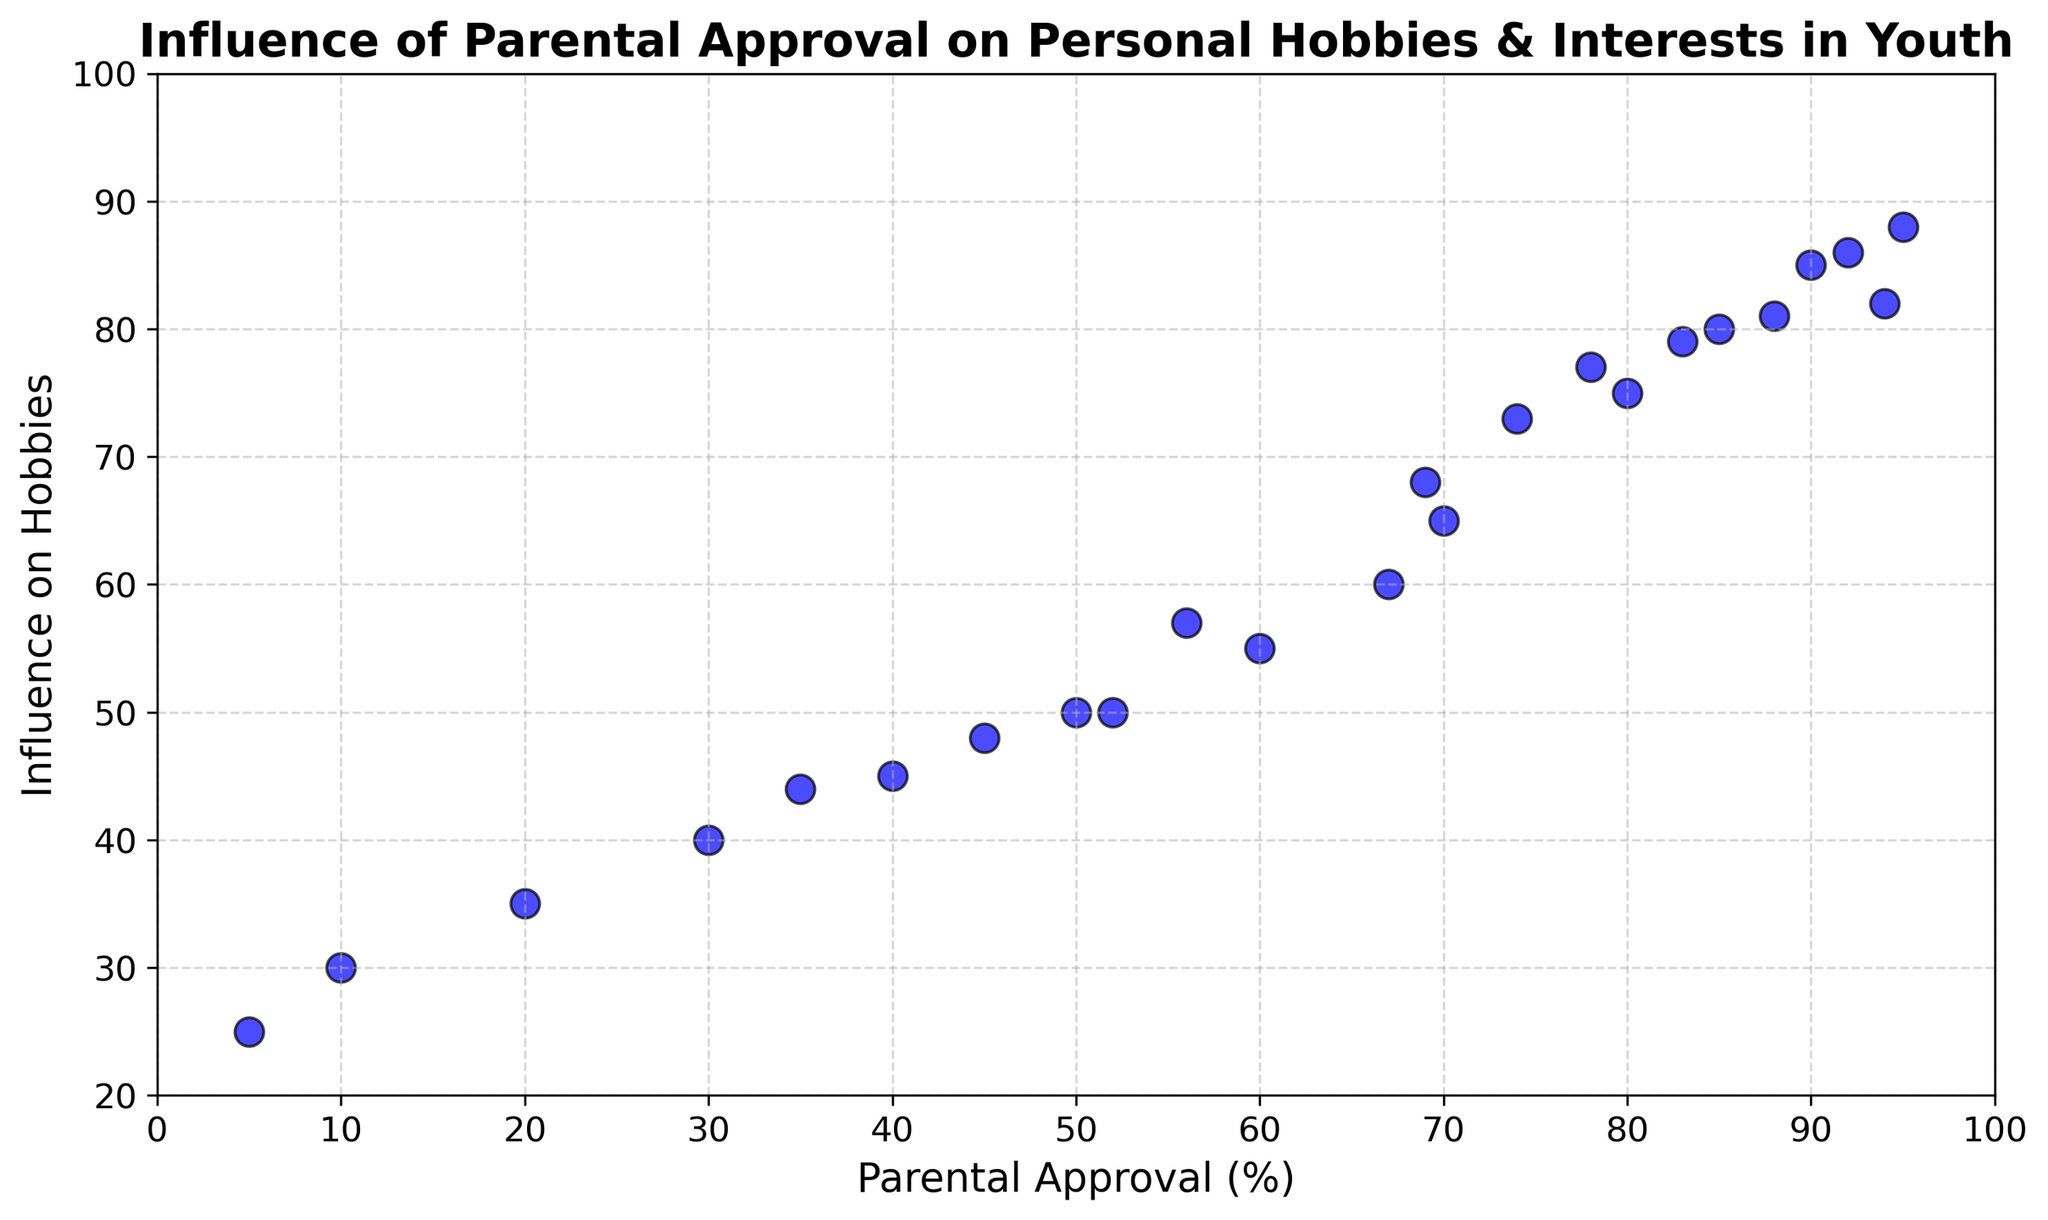What range of values does the parental approval percentage fall into? The x-axis represents the parental approval percentage, and the scatter plots span from a low of 5 to a high of 95.
Answer: 5 to 95 What is the relationship between parental approval and influence on hobbies as depicted by the scatter plot? Observing the scatter plot, it shows a general trend where higher parental approval correlates with higher influence on hobbies, indicating a positive relationship.
Answer: Positive relationship What is the minimum value of influence on hobbies shown on the chart? The y-axis represents the influence on hobbies, and the lowest data point on this axis is at 25.
Answer: 25 How many data points show a parental approval of 85% or higher? By counting the points on the scatter plot where parental approval % is 85 or higher, we see they are at positions 85-80, 90-85, 95-88, 92-86, 94-82, and 88-81, amounting to six data points.
Answer: 6 Which data point has the highest influence on hobbies value and what is its corresponding parental approval percentage? The highest influence on hobbies value is 88 (corresponding to a parental approval of 95%). By scanning the y-axis, we associate it with the x-axis value.
Answer: 95, 88 What is the range for the influence on hobbies values? The y-axis ranges from the minimum value on influence (25) to the maximum value (88), giving a range of 88 - 25.
Answer: 63 Are there more data points with parental approval above 50% or below 50%? By counting the points, there are 18 data points with parental approval above 50%, and only 6 data points below 50%.
Answer: Above 50% What is the average influence on hobbies for data points with parental approval below 50%? The points below 50% parental approval have values of 25, 30, 35, 40, 44, and 45. Summing these gives 25 + 30 + 35 + 40 + 44 + 45 = 219. Dividing by 6 (number of points) gives 219/6 = 36.5.
Answer: 36.5 Is there a higher concentration of data points in the lower or upper ranges of parental approval percentages? By observing the density of points on the scatter plot, there’s a higher concentration in the upper range (60-95%) than in the lower range (5-55%).
Answer: Upper range What is the median value of influence on hobbies? Sorting the influence values: 25, 30, 35, 40, 44, 45, 48, 50, 50, 55, 57, 60, 65, 68, 73, 75, 77, 79, 80, 81, 82, 85, 86, 88. The median is the middle value or average of two middle values. Here the two middle values are 60 and 65, so the median is (60+65)/2 = 62.5.
Answer: 62.5 